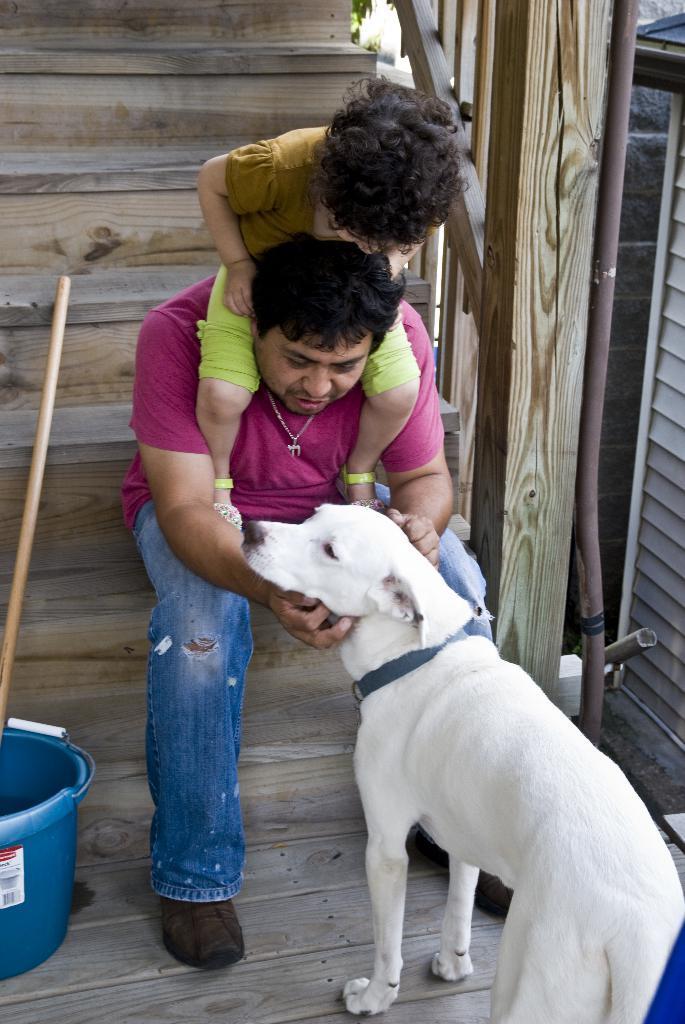Could you give a brief overview of what you see in this image? In this picture there is a man who is sitting on the stairs and there is a dog in front of him, the man is playing with the girl as she is sitting on his shoulders and there is a door at the right side of the image. 